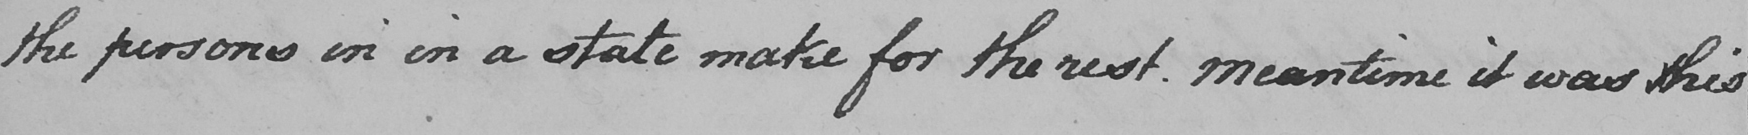Please transcribe the handwritten text in this image. the persons in in a state make for the rest . Meantime it was this 